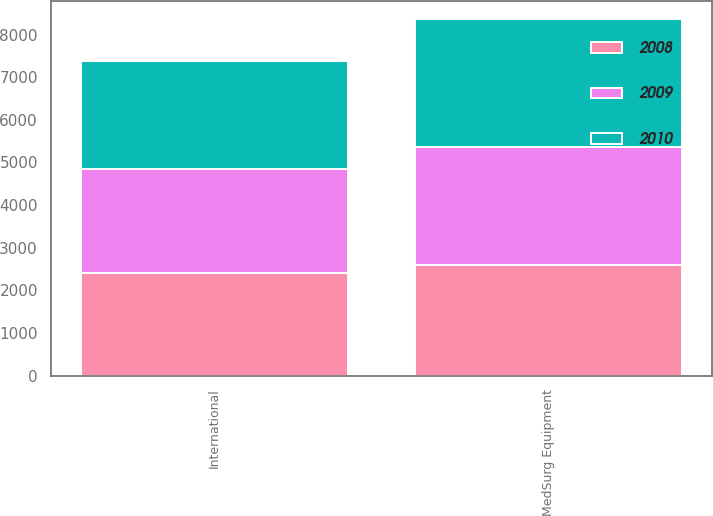Convert chart. <chart><loc_0><loc_0><loc_500><loc_500><stacked_bar_chart><ecel><fcel>International<fcel>MedSurg Equipment<nl><fcel>2010<fcel>2527.2<fcel>3011.6<nl><fcel>2008<fcel>2405.7<fcel>2603.4<nl><fcel>2009<fcel>2436<fcel>2750.7<nl></chart> 